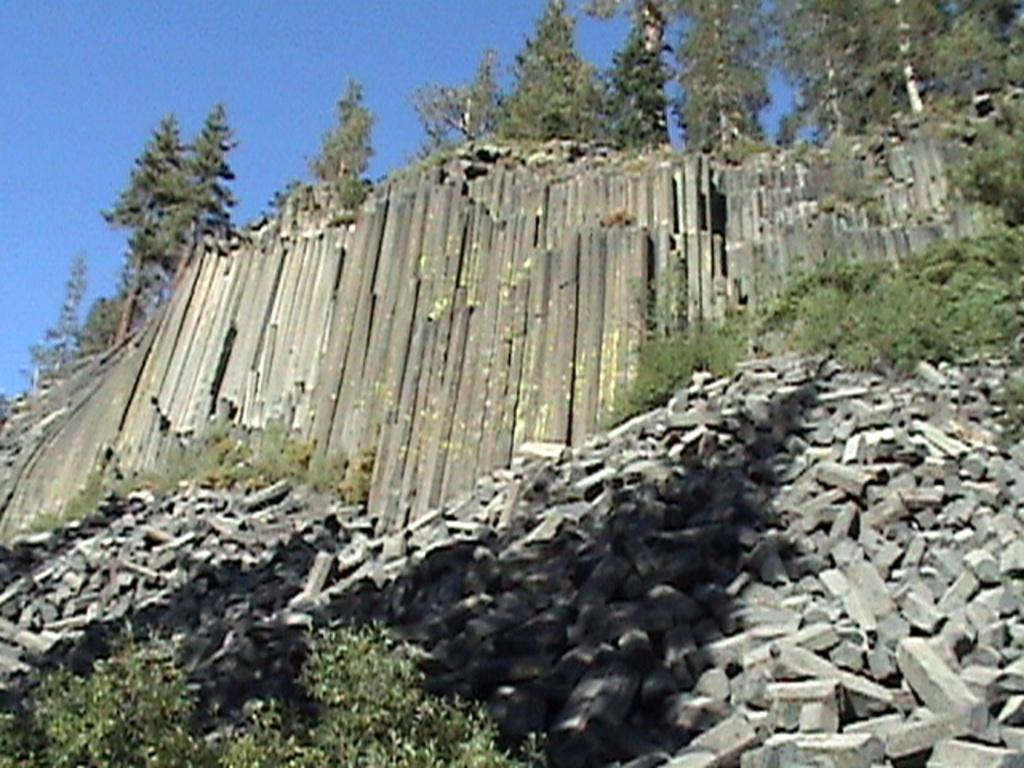What is located at the bottom of the image? There are plants and stones at the bottom of the image. What type of structure is present in the image? There is a wall with rocks in the image. What can be seen in the background of the image? There are trees in the background of the image. What is visible at the top of the image? The sky is visible at the top of the image. Can you hear the fowl in the image? There is no auditory information provided in the image, and therefore it is not possible to determine if fowl can be heard. Additionally, there is no mention of fowl in the provided facts. 